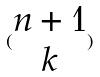Convert formula to latex. <formula><loc_0><loc_0><loc_500><loc_500>( \begin{matrix} n + 1 \\ k \end{matrix} )</formula> 